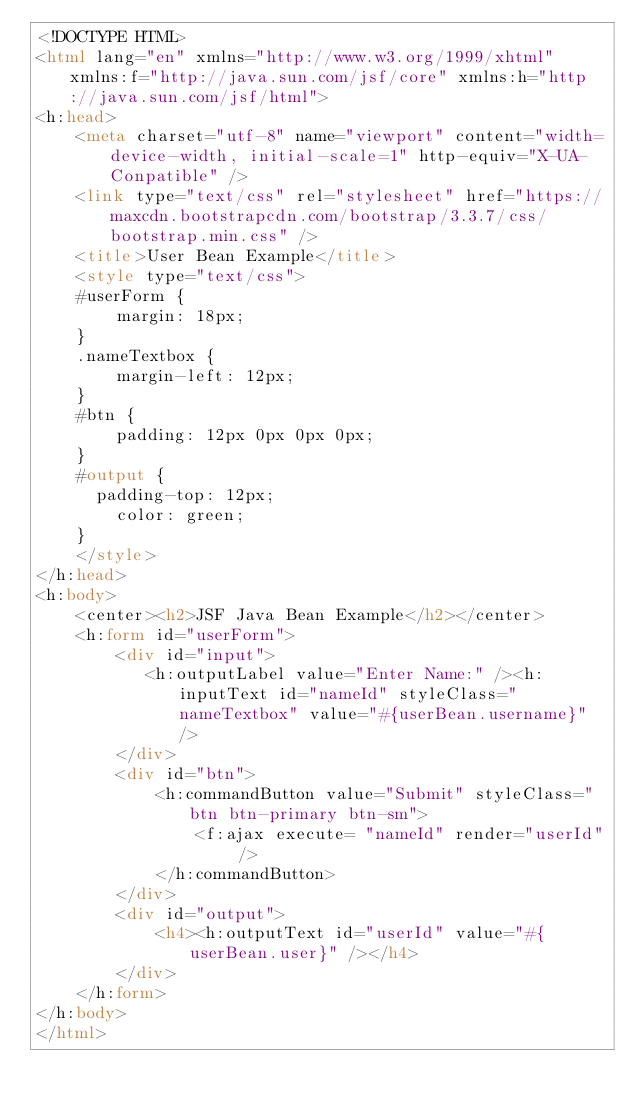<code> <loc_0><loc_0><loc_500><loc_500><_HTML_><!DOCTYPE HTML>
<html lang="en" xmlns="http://www.w3.org/1999/xhtml" xmlns:f="http://java.sun.com/jsf/core" xmlns:h="http://java.sun.com/jsf/html">
<h:head>
    <meta charset="utf-8" name="viewport" content="width=device-width, initial-scale=1" http-equiv="X-UA-Conpatible" />
    <link type="text/css" rel="stylesheet" href="https://maxcdn.bootstrapcdn.com/bootstrap/3.3.7/css/bootstrap.min.css" />    
    <title>User Bean Example</title>
    <style type="text/css">
    #userForm {
		    margin: 18px;
		}
		.nameTextbox {
		    margin-left: 12px;
		}
		#btn {
		    padding: 12px 0px 0px 0px;
		}
		#output {
			padding-top: 12px;
		    color: green;
		}
    </style>
</h:head>
<h:body>
    <center><h2>JSF Java Bean Example</h2></center>
    <h:form id="userForm">       
        <div id="input">
        	 <h:outputLabel value="Enter Name:" /><h:inputText id="nameId" styleClass="nameTextbox" value="#{userBean.username}" />
        </div>
        <div id="btn">
            <h:commandButton value="Submit" styleClass="btn btn-primary btn-sm">
                <f:ajax execute= "nameId" render="userId" />
            </h:commandButton>
        </div>
        <div id="output">
            <h4><h:outputText id="userId" value="#{userBean.user}" /></h4>
        </div>
    </h:form>
</h:body>
</html></code> 